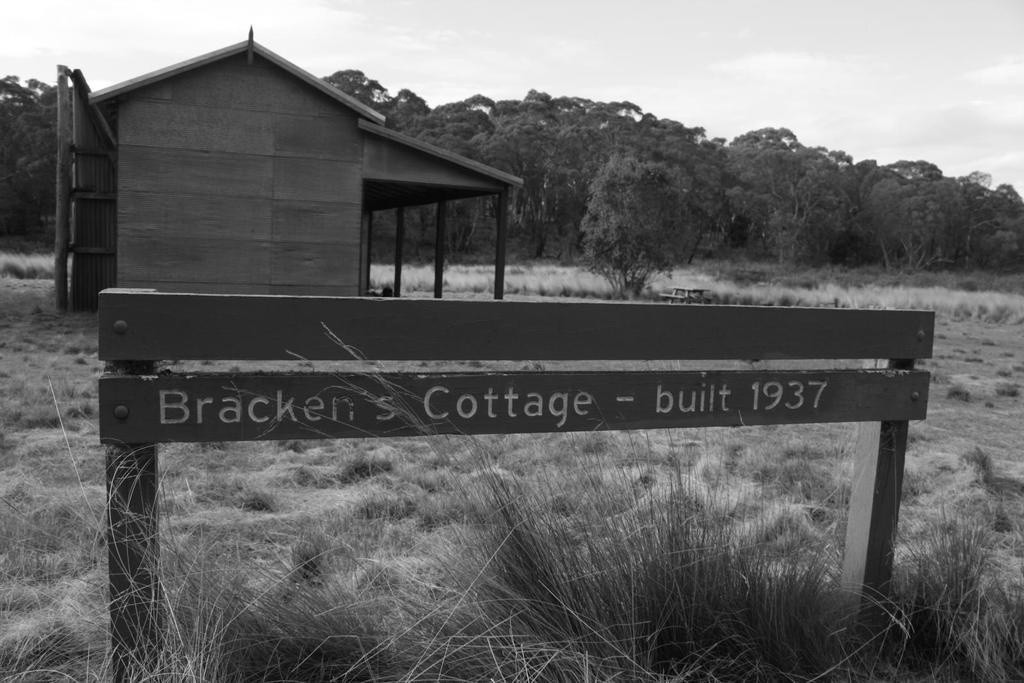What is the main object in the foreground of the image? There is a hurdle in the foreground of the image. What can be seen in the background of the image? There are trees, grassland, a house structure, and the sky visible in the background of the image. What type of vegetation is present in the background? There are trees in the background of the image. What is the natural environment like in the image? The natural environment includes grassland and trees. What type of locket is hanging from the tree in the image? There is no locket present in the image; it only features a hurdle in the foreground and various elements in the background. Can you tell me how many dogs are running around the hurdle in the image? There are no dogs present in the image; it only features a hurdle in the foreground and various elements in the background. 